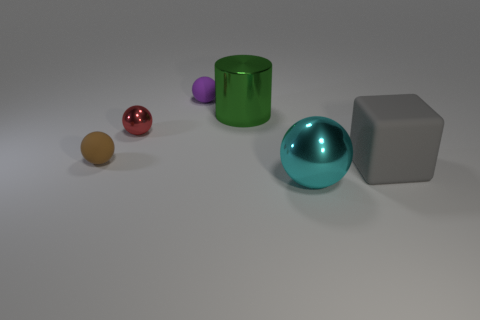Subtract all cyan balls. Subtract all green cubes. How many balls are left? 3 Add 2 large cyan things. How many objects exist? 8 Subtract all balls. How many objects are left? 2 Add 3 brown cylinders. How many brown cylinders exist? 3 Subtract 0 blue blocks. How many objects are left? 6 Subtract all brown spheres. Subtract all small gray rubber objects. How many objects are left? 5 Add 4 cyan metallic spheres. How many cyan metallic spheres are left? 5 